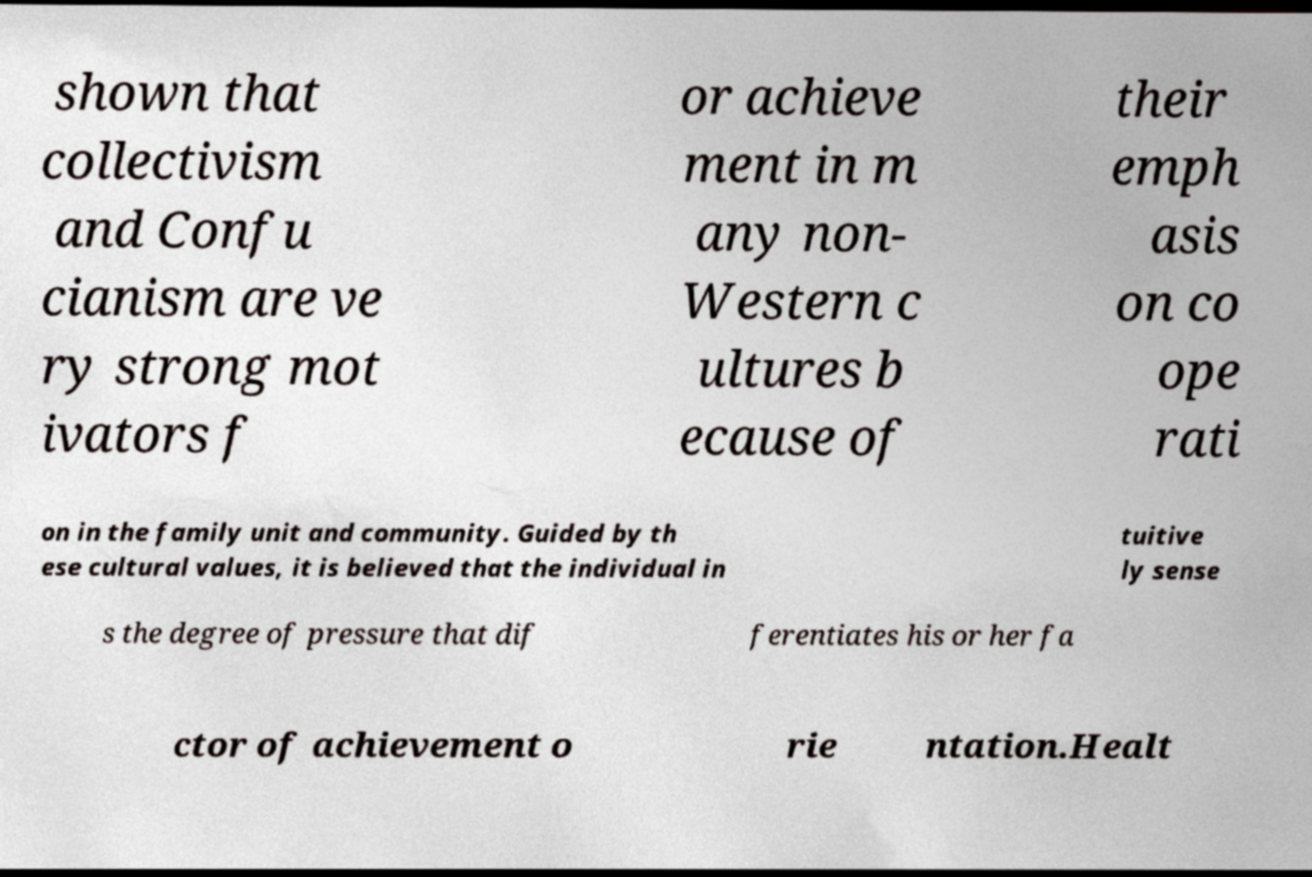Please identify and transcribe the text found in this image. shown that collectivism and Confu cianism are ve ry strong mot ivators f or achieve ment in m any non- Western c ultures b ecause of their emph asis on co ope rati on in the family unit and community. Guided by th ese cultural values, it is believed that the individual in tuitive ly sense s the degree of pressure that dif ferentiates his or her fa ctor of achievement o rie ntation.Healt 